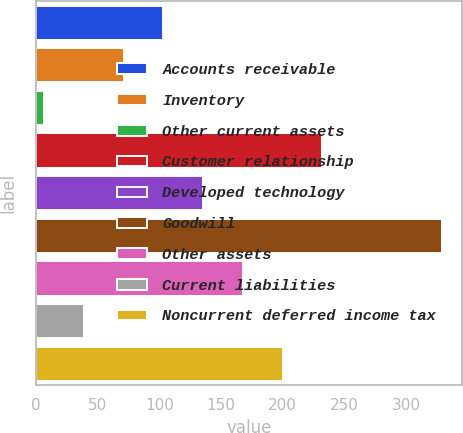Convert chart to OTSL. <chart><loc_0><loc_0><loc_500><loc_500><bar_chart><fcel>Accounts receivable<fcel>Inventory<fcel>Other current assets<fcel>Customer relationship<fcel>Developed technology<fcel>Goodwill<fcel>Other assets<fcel>Current liabilities<fcel>Noncurrent deferred income tax<nl><fcel>103.14<fcel>70.86<fcel>6.3<fcel>232.26<fcel>135.42<fcel>329.1<fcel>167.7<fcel>38.58<fcel>199.98<nl></chart> 